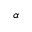Convert formula to latex. <formula><loc_0><loc_0><loc_500><loc_500>\alpha</formula> 